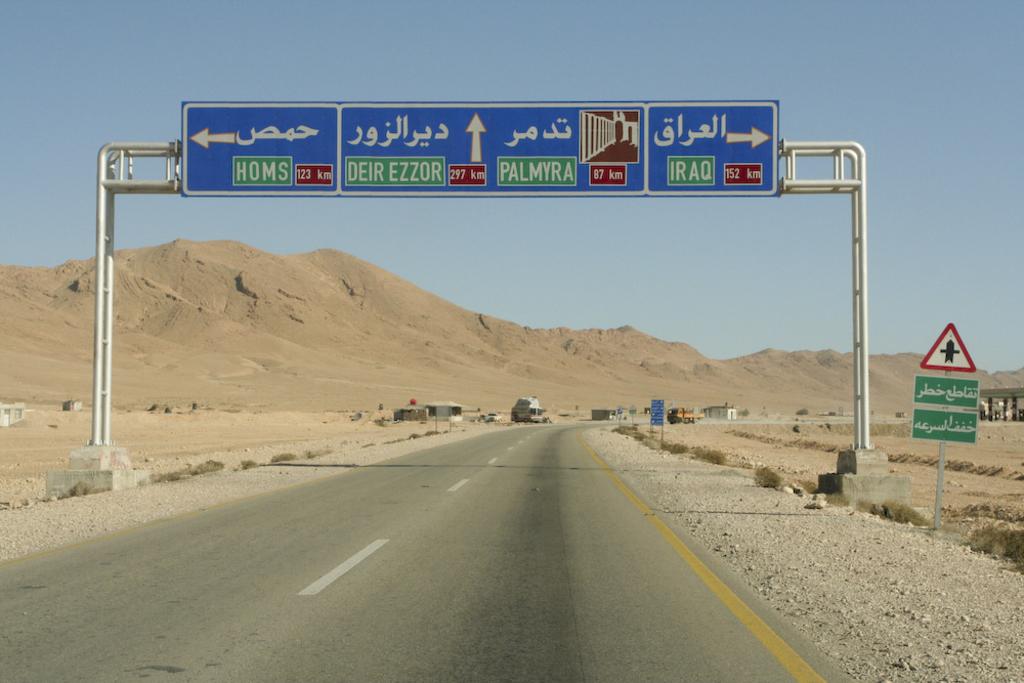If you follow the road to the left where will you go?
Your response must be concise. Homs. 